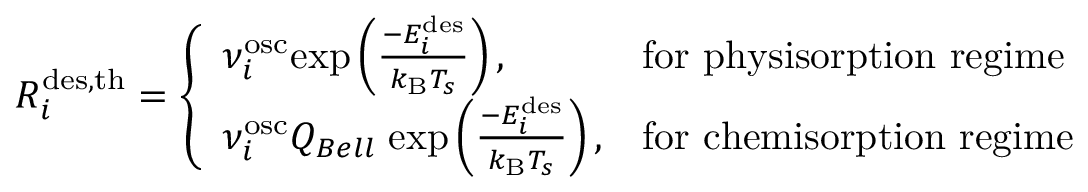Convert formula to latex. <formula><loc_0><loc_0><loc_500><loc_500>R _ { i } ^ { d e s , t h } = \left \{ \begin{array} { l l } { \nu _ { i } ^ { o s c } e x p \left ( \frac { - E _ { i } ^ { d e s } } { k _ { B } T _ { s } } \right ) , } & { f o r p h y s i s o r p t i o n r e g i m e } \\ { \nu _ { i } ^ { o s c } Q _ { B e l l } \, e x p \left ( \frac { - E _ { i } ^ { d e s } } { k _ { B } T _ { s } } \right ) , } & { f o r c h e m i s o r p t i o n r e g i m e } \end{array}</formula> 